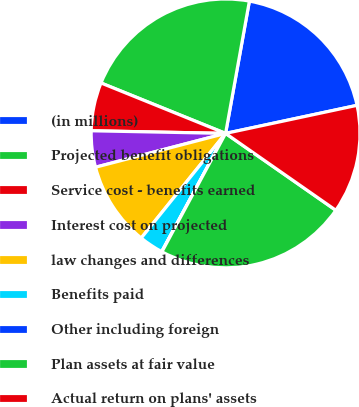<chart> <loc_0><loc_0><loc_500><loc_500><pie_chart><fcel>(in millions)<fcel>Projected benefit obligations<fcel>Service cost - benefits earned<fcel>Interest cost on projected<fcel>law changes and differences<fcel>Benefits paid<fcel>Other including foreign<fcel>Plan assets at fair value<fcel>Actual return on plans' assets<nl><fcel>18.82%<fcel>21.71%<fcel>5.81%<fcel>4.36%<fcel>10.15%<fcel>2.92%<fcel>0.03%<fcel>23.16%<fcel>13.04%<nl></chart> 